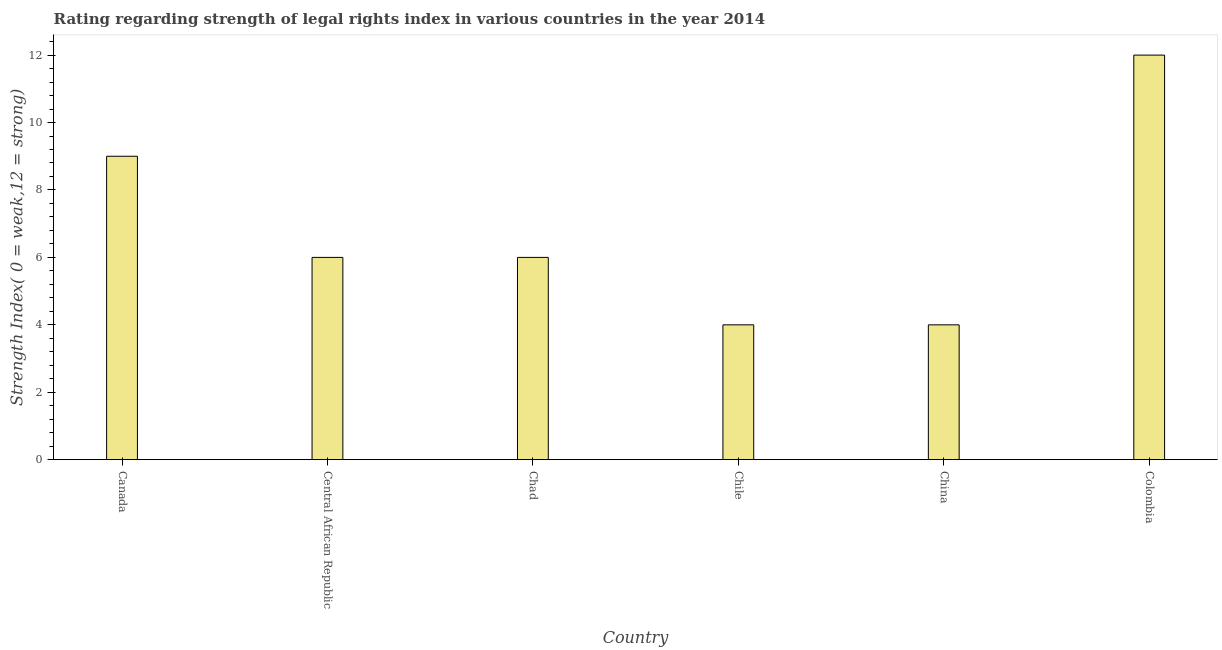Does the graph contain any zero values?
Ensure brevity in your answer.  No. What is the title of the graph?
Provide a succinct answer. Rating regarding strength of legal rights index in various countries in the year 2014. What is the label or title of the X-axis?
Offer a very short reply. Country. What is the label or title of the Y-axis?
Provide a succinct answer. Strength Index( 0 = weak,12 = strong). What is the strength of legal rights index in Colombia?
Provide a short and direct response. 12. Across all countries, what is the maximum strength of legal rights index?
Offer a terse response. 12. In which country was the strength of legal rights index maximum?
Give a very brief answer. Colombia. What is the sum of the strength of legal rights index?
Offer a terse response. 41. What is the average strength of legal rights index per country?
Make the answer very short. 6.83. What is the median strength of legal rights index?
Ensure brevity in your answer.  6. Is the strength of legal rights index in Chad less than that in Colombia?
Your answer should be compact. Yes. What is the difference between the highest and the lowest strength of legal rights index?
Your answer should be compact. 8. In how many countries, is the strength of legal rights index greater than the average strength of legal rights index taken over all countries?
Make the answer very short. 2. Are all the bars in the graph horizontal?
Provide a short and direct response. No. How many countries are there in the graph?
Your answer should be compact. 6. Are the values on the major ticks of Y-axis written in scientific E-notation?
Your response must be concise. No. What is the Strength Index( 0 = weak,12 = strong) in Canada?
Give a very brief answer. 9. What is the Strength Index( 0 = weak,12 = strong) of Central African Republic?
Provide a succinct answer. 6. What is the Strength Index( 0 = weak,12 = strong) in China?
Provide a succinct answer. 4. What is the difference between the Strength Index( 0 = weak,12 = strong) in Canada and Central African Republic?
Your answer should be very brief. 3. What is the difference between the Strength Index( 0 = weak,12 = strong) in Canada and China?
Ensure brevity in your answer.  5. What is the difference between the Strength Index( 0 = weak,12 = strong) in Chad and Chile?
Your answer should be very brief. 2. What is the difference between the Strength Index( 0 = weak,12 = strong) in Chile and China?
Your answer should be very brief. 0. What is the difference between the Strength Index( 0 = weak,12 = strong) in Chile and Colombia?
Provide a short and direct response. -8. What is the difference between the Strength Index( 0 = weak,12 = strong) in China and Colombia?
Your answer should be compact. -8. What is the ratio of the Strength Index( 0 = weak,12 = strong) in Canada to that in Central African Republic?
Keep it short and to the point. 1.5. What is the ratio of the Strength Index( 0 = weak,12 = strong) in Canada to that in Chad?
Keep it short and to the point. 1.5. What is the ratio of the Strength Index( 0 = weak,12 = strong) in Canada to that in Chile?
Keep it short and to the point. 2.25. What is the ratio of the Strength Index( 0 = weak,12 = strong) in Canada to that in China?
Your answer should be compact. 2.25. What is the ratio of the Strength Index( 0 = weak,12 = strong) in Canada to that in Colombia?
Your answer should be compact. 0.75. What is the ratio of the Strength Index( 0 = weak,12 = strong) in Central African Republic to that in Chile?
Provide a succinct answer. 1.5. What is the ratio of the Strength Index( 0 = weak,12 = strong) in Central African Republic to that in Colombia?
Offer a terse response. 0.5. What is the ratio of the Strength Index( 0 = weak,12 = strong) in Chile to that in China?
Provide a succinct answer. 1. What is the ratio of the Strength Index( 0 = weak,12 = strong) in Chile to that in Colombia?
Ensure brevity in your answer.  0.33. What is the ratio of the Strength Index( 0 = weak,12 = strong) in China to that in Colombia?
Your answer should be compact. 0.33. 